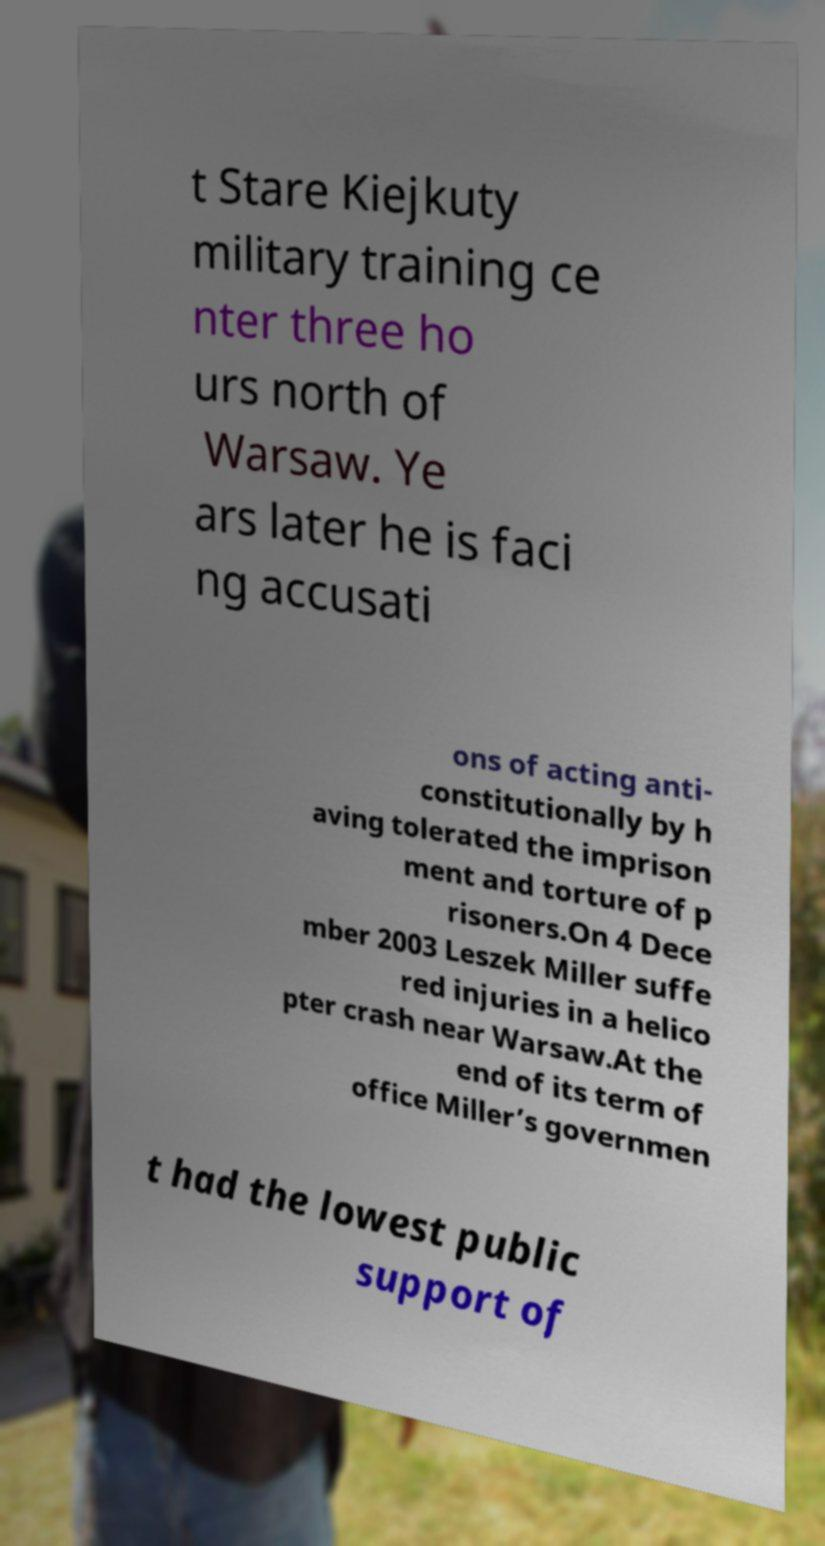For documentation purposes, I need the text within this image transcribed. Could you provide that? t Stare Kiejkuty military training ce nter three ho urs north of Warsaw. Ye ars later he is faci ng accusati ons of acting anti- constitutionally by h aving tolerated the imprison ment and torture of p risoners.On 4 Dece mber 2003 Leszek Miller suffe red injuries in a helico pter crash near Warsaw.At the end of its term of office Miller’s governmen t had the lowest public support of 